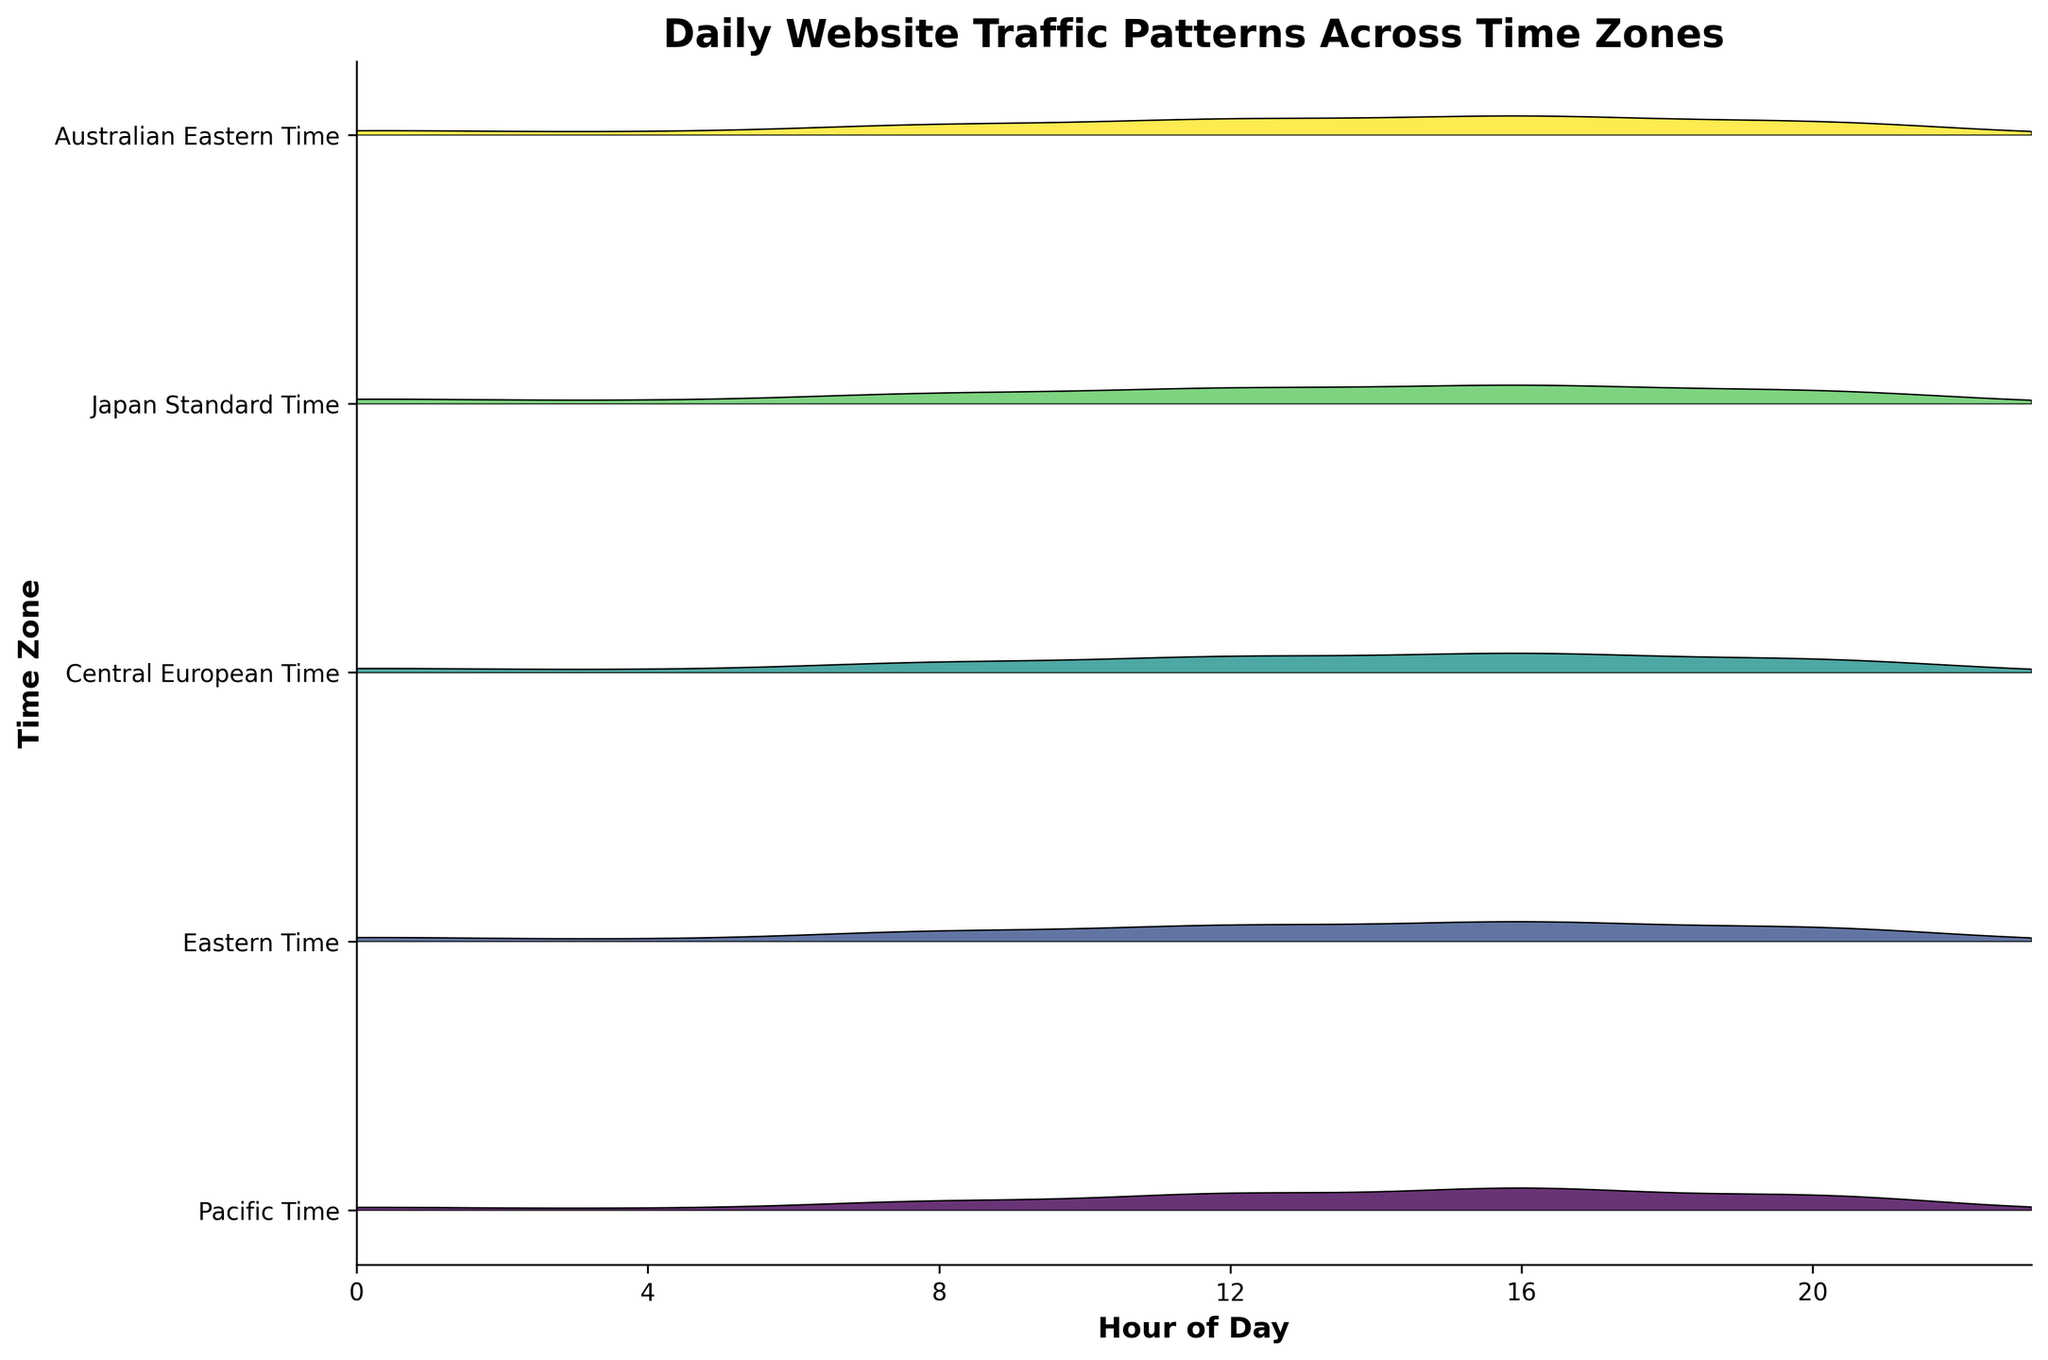What's the title of the figure? The title is usually displayed at the top of the figure, providing a summary of what the plot is about. Here, it should describe the daily website traffic patterns across different time zones.
Answer: Daily Website Traffic Patterns Across Time Zones Which time zone shows the highest traffic during hour 16? To find this, locate 16 on the x-axis and see which curve peaks the highest at this hour.
Answer: Australian Eastern Time What is the traffic pattern in the Japan Standard Time zone around hour 12? Examine the curve corresponding to Japan Standard Time at the 12th hour. It should indicate the traffic level around this time.
Answer: High How does the traffic in Central European Time during hour 8 compare to the traffic in Pacific Time during the same hour? Locate hour 8 on the x-axis for both Central European Time and Pacific Time. Compare the heights of the curves at this point.
Answer: Central European Time has higher traffic Which time zone has the most consistent traffic across all hours? Look for a curve that remains relatively flat and close to the same level across all hours of the day.
Answer: Central European Time What is the average traffic during hour 0 across all time zones? Find the traffic levels at hour 0 for all time zones: Pacific Time (150), Eastern Time (280), Central European Time (320), Japan Standard Time (400), and Australian Eastern Time (350). Sum these values and divide by the number of time zones.
Answer: 300 For the hour 12, which time zone shows lower traffic compared to Pacific Time? Observe the traffic levels for each time zone at hour 12 and compare them to Pacific Time (820). Identify those with lower values.
Answer: Eastern Time Which time zone shows a significant increase in traffic from hour 8 to hour 12? Check the curve of each time zone to see which shows a steep incline between 8 and 12.
Answer: Central European Time Is the traffic pattern in Eastern Time zone more variable than in Japan Standard Time? Compare the fluctuation of the curves representing traffic levels at different hours in both time zones. Larger variations indicate more variability.
Answer: No 